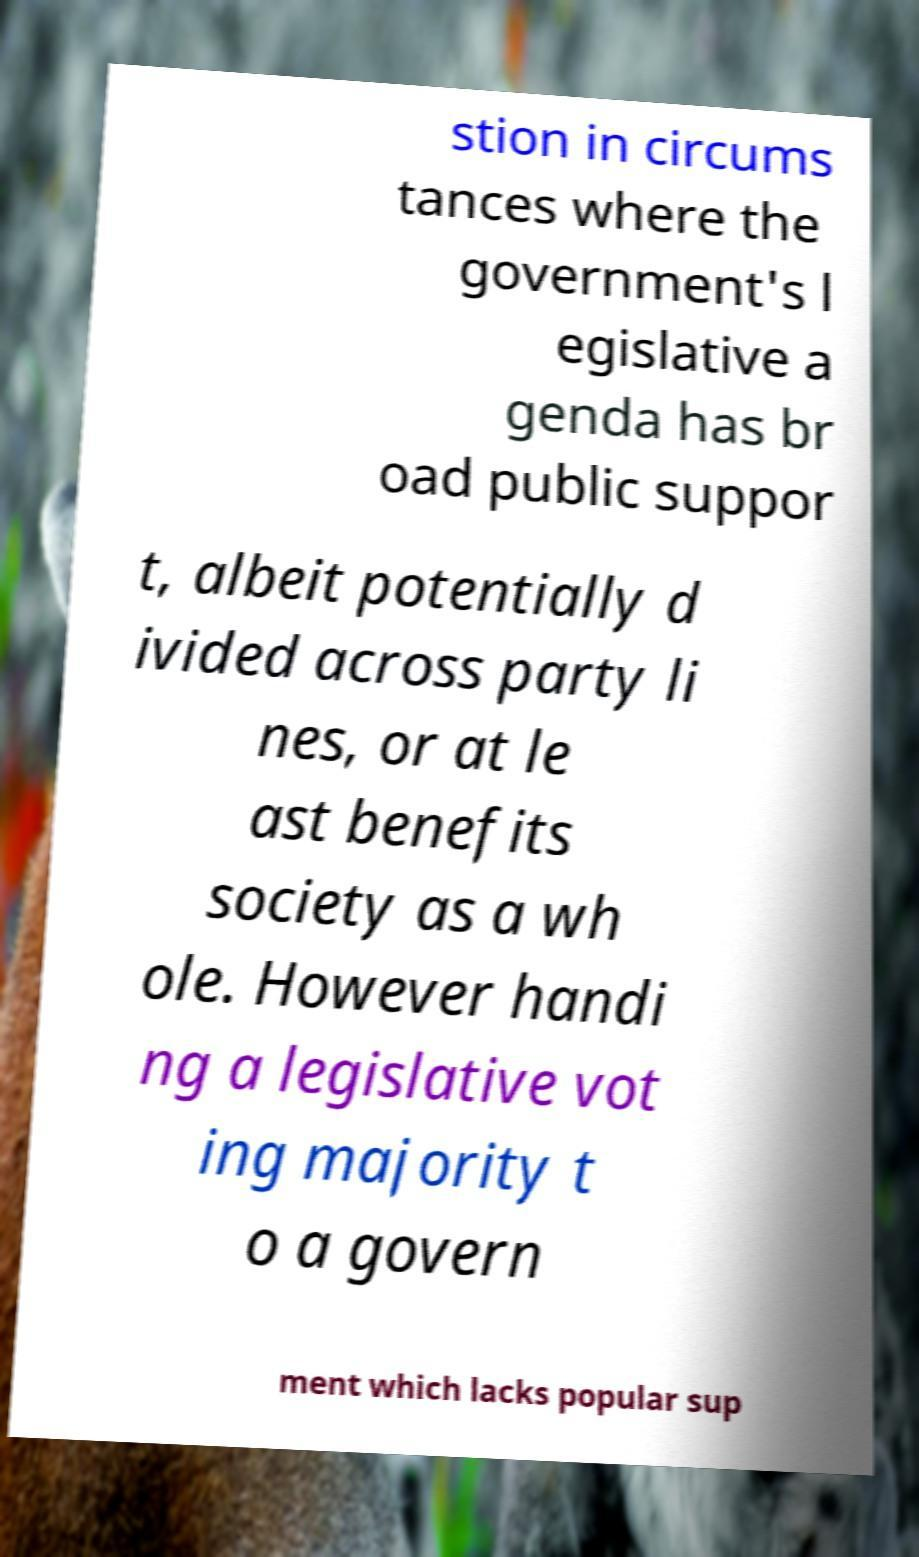For documentation purposes, I need the text within this image transcribed. Could you provide that? stion in circums tances where the government's l egislative a genda has br oad public suppor t, albeit potentially d ivided across party li nes, or at le ast benefits society as a wh ole. However handi ng a legislative vot ing majority t o a govern ment which lacks popular sup 